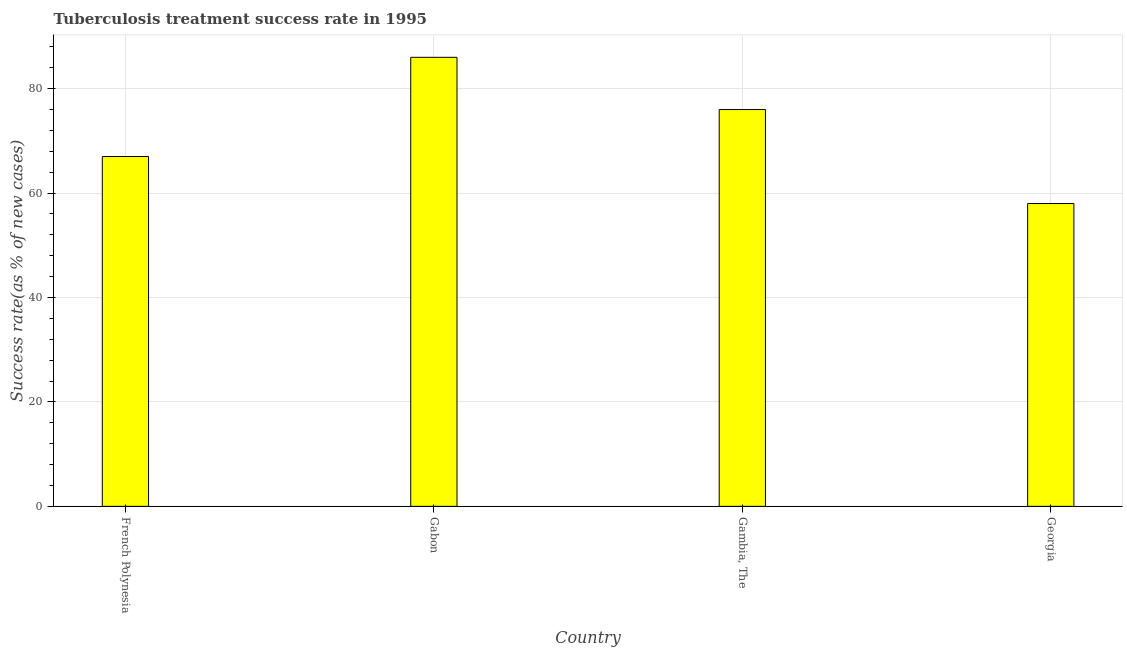Does the graph contain any zero values?
Ensure brevity in your answer.  No. What is the title of the graph?
Ensure brevity in your answer.  Tuberculosis treatment success rate in 1995. What is the label or title of the Y-axis?
Ensure brevity in your answer.  Success rate(as % of new cases). What is the tuberculosis treatment success rate in French Polynesia?
Keep it short and to the point. 67. Across all countries, what is the maximum tuberculosis treatment success rate?
Your response must be concise. 86. Across all countries, what is the minimum tuberculosis treatment success rate?
Provide a succinct answer. 58. In which country was the tuberculosis treatment success rate maximum?
Keep it short and to the point. Gabon. In which country was the tuberculosis treatment success rate minimum?
Make the answer very short. Georgia. What is the sum of the tuberculosis treatment success rate?
Ensure brevity in your answer.  287. What is the average tuberculosis treatment success rate per country?
Your answer should be compact. 71. What is the median tuberculosis treatment success rate?
Your answer should be very brief. 71.5. In how many countries, is the tuberculosis treatment success rate greater than 12 %?
Offer a very short reply. 4. What is the ratio of the tuberculosis treatment success rate in Gabon to that in Gambia, The?
Offer a terse response. 1.13. What is the difference between the highest and the second highest tuberculosis treatment success rate?
Your answer should be compact. 10. Is the sum of the tuberculosis treatment success rate in Gabon and Georgia greater than the maximum tuberculosis treatment success rate across all countries?
Give a very brief answer. Yes. What is the difference between the highest and the lowest tuberculosis treatment success rate?
Make the answer very short. 28. How many bars are there?
Ensure brevity in your answer.  4. Are all the bars in the graph horizontal?
Your answer should be very brief. No. Are the values on the major ticks of Y-axis written in scientific E-notation?
Your response must be concise. No. What is the Success rate(as % of new cases) in French Polynesia?
Your response must be concise. 67. What is the Success rate(as % of new cases) of Georgia?
Provide a succinct answer. 58. What is the difference between the Success rate(as % of new cases) in French Polynesia and Gabon?
Make the answer very short. -19. What is the difference between the Success rate(as % of new cases) in Gabon and Gambia, The?
Make the answer very short. 10. What is the difference between the Success rate(as % of new cases) in Gabon and Georgia?
Your response must be concise. 28. What is the difference between the Success rate(as % of new cases) in Gambia, The and Georgia?
Your answer should be compact. 18. What is the ratio of the Success rate(as % of new cases) in French Polynesia to that in Gabon?
Provide a short and direct response. 0.78. What is the ratio of the Success rate(as % of new cases) in French Polynesia to that in Gambia, The?
Your response must be concise. 0.88. What is the ratio of the Success rate(as % of new cases) in French Polynesia to that in Georgia?
Offer a terse response. 1.16. What is the ratio of the Success rate(as % of new cases) in Gabon to that in Gambia, The?
Give a very brief answer. 1.13. What is the ratio of the Success rate(as % of new cases) in Gabon to that in Georgia?
Your answer should be very brief. 1.48. What is the ratio of the Success rate(as % of new cases) in Gambia, The to that in Georgia?
Your answer should be compact. 1.31. 